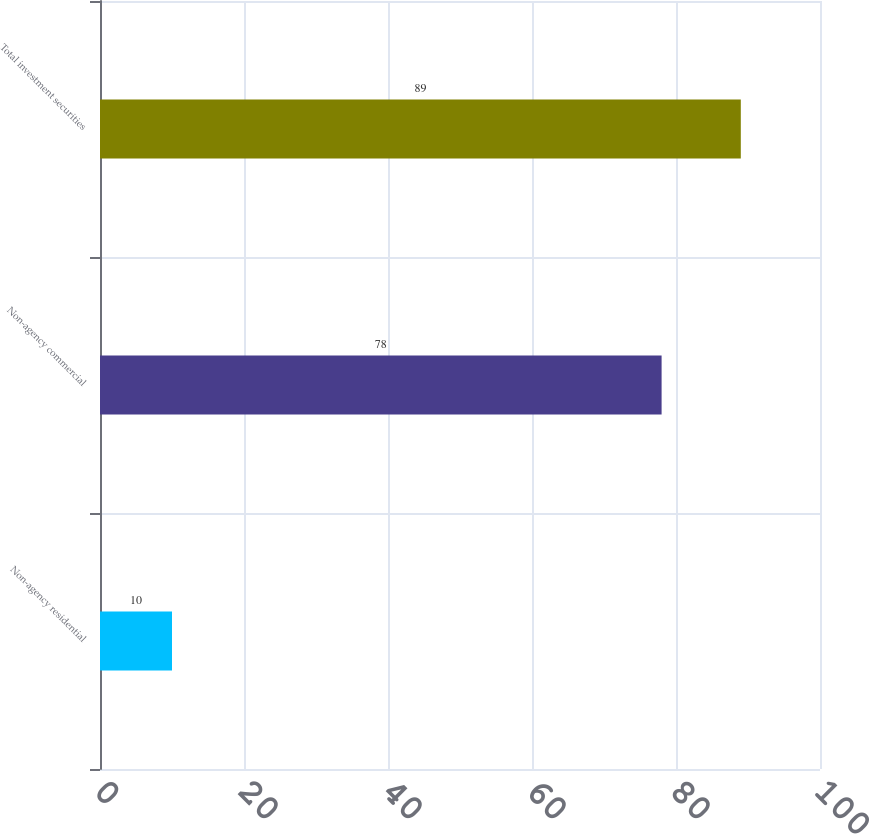Convert chart to OTSL. <chart><loc_0><loc_0><loc_500><loc_500><bar_chart><fcel>Non-agency residential<fcel>Non-agency commercial<fcel>Total investment securities<nl><fcel>10<fcel>78<fcel>89<nl></chart> 